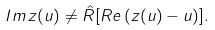Convert formula to latex. <formula><loc_0><loc_0><loc_500><loc_500>I m \, z ( u ) \not = \hat { R } [ R e \, ( z ( u ) - u ) ] .</formula> 